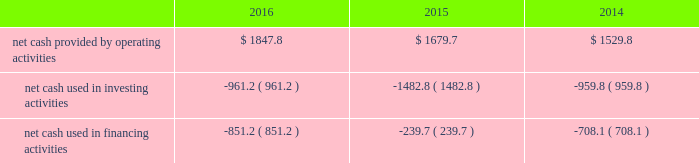Liquidity and capital resources the major components of changes in cash flows for 2016 , 2015 and 2014 are discussed in the following paragraphs .
The table summarizes our cash flow from operating activities , investing activities and financing activities for the years ended december 31 , 2016 , 2015 and 2014 ( in millions of dollars ) : .
Cash flows provided by operating activities the most significant items affecting the comparison of our operating cash flows for 2016 and 2015 are summarized below : changes in assets and liabilities , net of effects from business acquisitions and divestitures , decreased our cash flow from operations by $ 205.2 million in 2016 , compared to a decrease of $ 316.7 million in 2015 , primarily as a result of the following : 2022 our accounts receivable , exclusive of the change in allowance for doubtful accounts and customer credits , increased $ 52.3 million during 2016 due to the timing of billings net of collections , compared to a $ 15.7 million increase in 2015 .
As of december 31 , 2016 and 2015 , our days sales outstanding were 38.1 and 38.3 days , or 26.1 and 25.8 days net of deferred revenue , respectively .
2022 our accounts payable decreased $ 9.8 million during 2016 compared to an increase of $ 35.6 million during 2015 , due to the timing of payments .
2022 cash paid for capping , closure and post-closure obligations was $ 11.0 million lower during 2016 compared to 2015 .
The decrease in cash paid for capping , closure , and post-closure obligations is primarily due to payments in 2015 related to a required capping event at one of our closed landfills .
2022 cash paid for remediation obligations was $ 13.2 million lower during 2016 compared to 2015 primarily due to the timing of obligations .
In addition , cash paid for income taxes was approximately $ 265 million and $ 321 million for 2016 and 2015 , respectively .
Income taxes paid in 2016 and 2015 reflect the favorable tax depreciation provisions of the protecting americans from tax hikes act signed into law in december 2015 as well as the realization of certain tax credits .
Cash paid for interest was $ 330.2 million and $ 327.6 million for 2016 and 2015 , respectively .
The most significant items affecting the comparison of our operating cash flows for 2015 and 2014 are summarized below : changes in assets and liabilities , net of effects of business acquisitions and divestitures , decreased our cash flow from operations by $ 316.7 million in 2015 , compared to a decrease of $ 295.6 million in 2014 , primarily as a result of the following : 2022 our accounts receivable , exclusive of the change in allowance for doubtful accounts and customer credits , increased $ 15.7 million during 2015 due to the timing of billings , net of collections , compared to a $ 54.3 million increase in 2014 .
As of december 31 , 2015 and 2014 , our days sales outstanding were 38 days , or 26 and 25 days net of deferred revenue , respectively .
2022 our accounts payable increased $ 35.6 million and $ 3.3 million during 2015 and 2014 , respectively , due to the timing of payments as of december 31 , 2015. .
What was the net change in cash in 2016 in millions? 
Rationale: the net change in cash is the sum of all change in the cash sources
Computations: (-851.2 + (1847.8 + -961.2))
Answer: 35.4. 